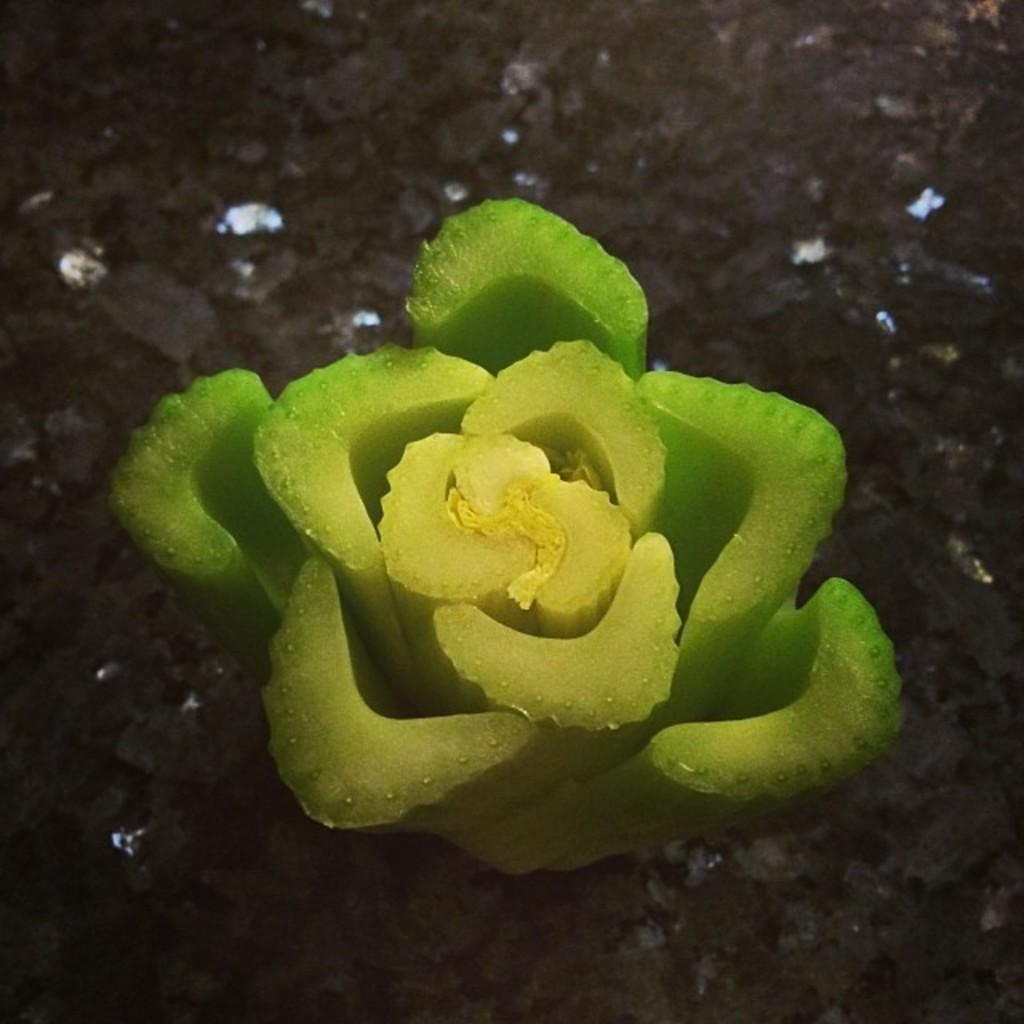What is the main subject of the image? The main subject of the image is a vegetable arranged like a flower. Where is the vegetable located in the image? The vegetable is on the ground in the image. What type of needle is used to create the flower pattern on the vegetable? There is no needle present in the image, and the vegetable is not being sewn or stitched. 